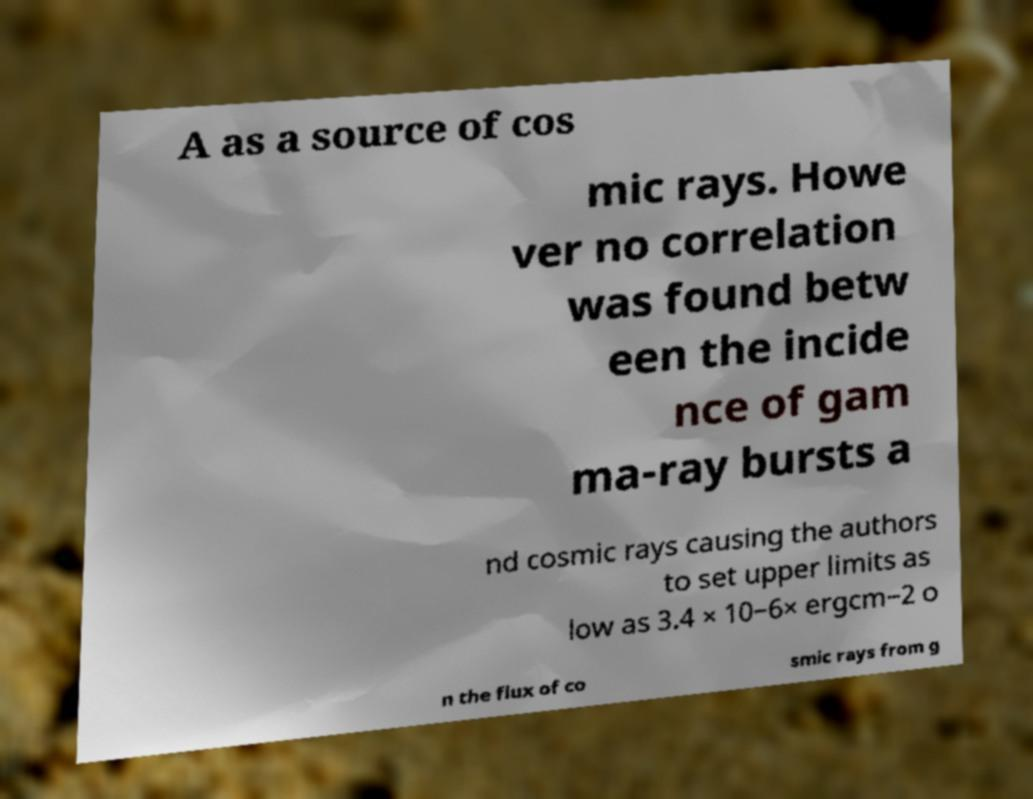What messages or text are displayed in this image? I need them in a readable, typed format. A as a source of cos mic rays. Howe ver no correlation was found betw een the incide nce of gam ma-ray bursts a nd cosmic rays causing the authors to set upper limits as low as 3.4 × 10−6× ergcm−2 o n the flux of co smic rays from g 